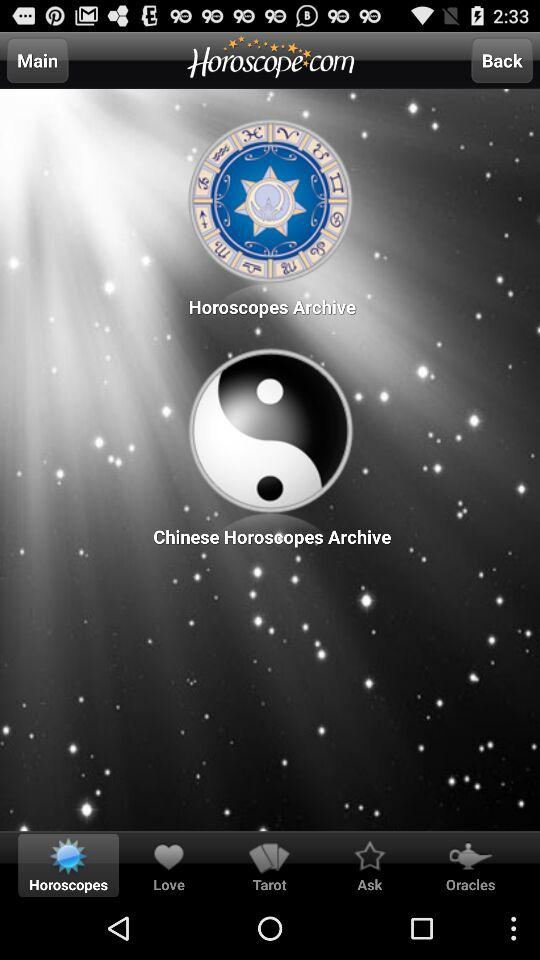Which tab is selected? The selected tab is "Horoscopes". 